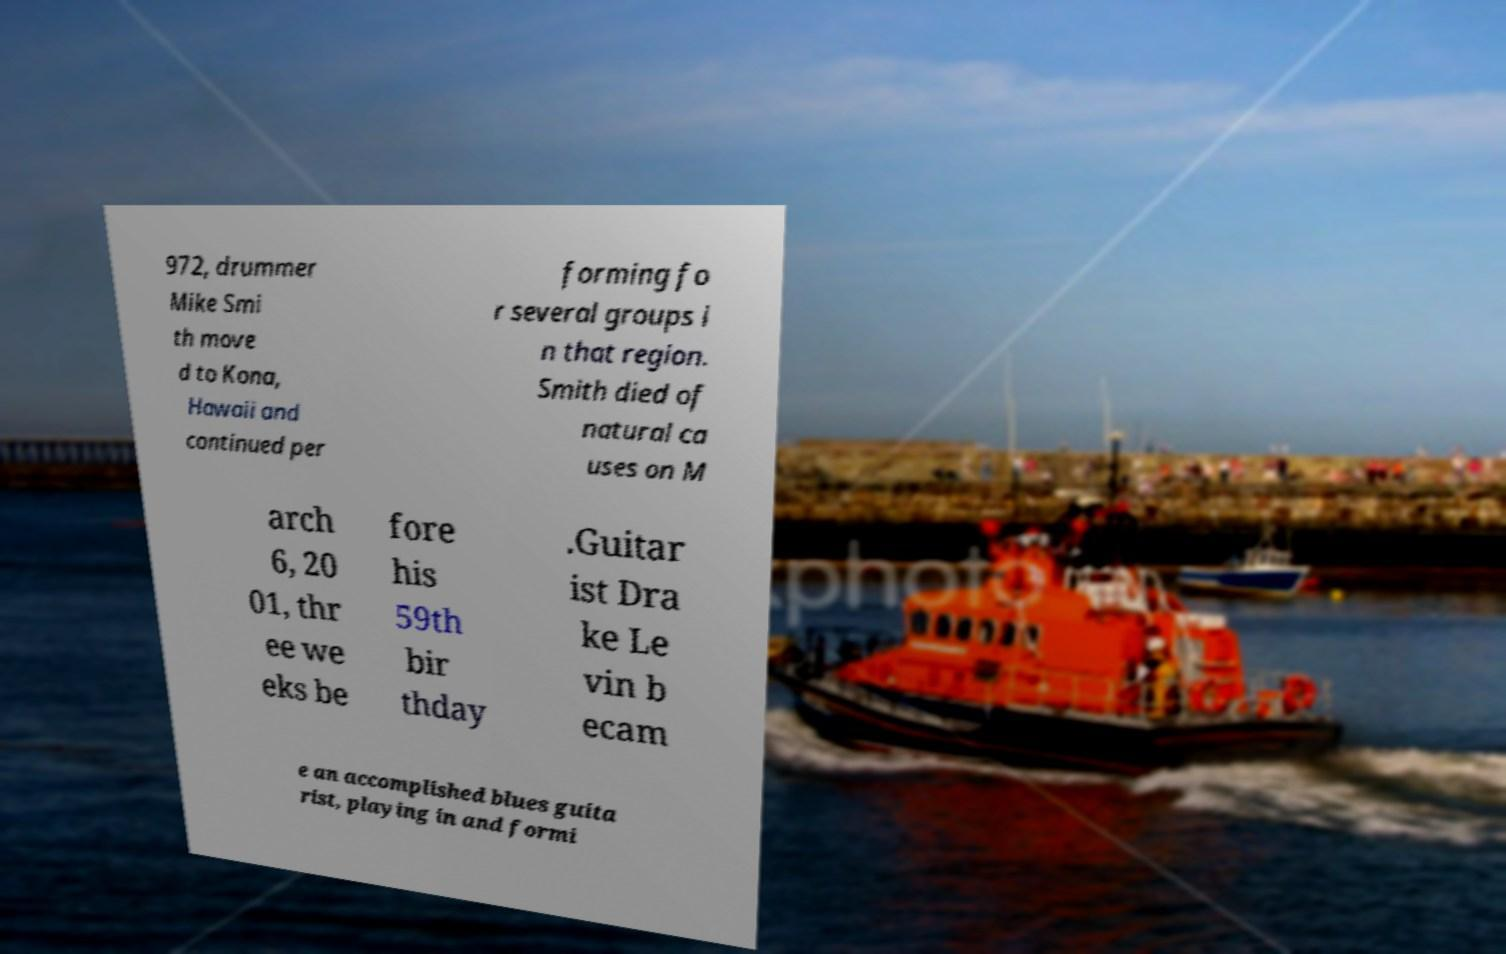Please identify and transcribe the text found in this image. 972, drummer Mike Smi th move d to Kona, Hawaii and continued per forming fo r several groups i n that region. Smith died of natural ca uses on M arch 6, 20 01, thr ee we eks be fore his 59th bir thday .Guitar ist Dra ke Le vin b ecam e an accomplished blues guita rist, playing in and formi 